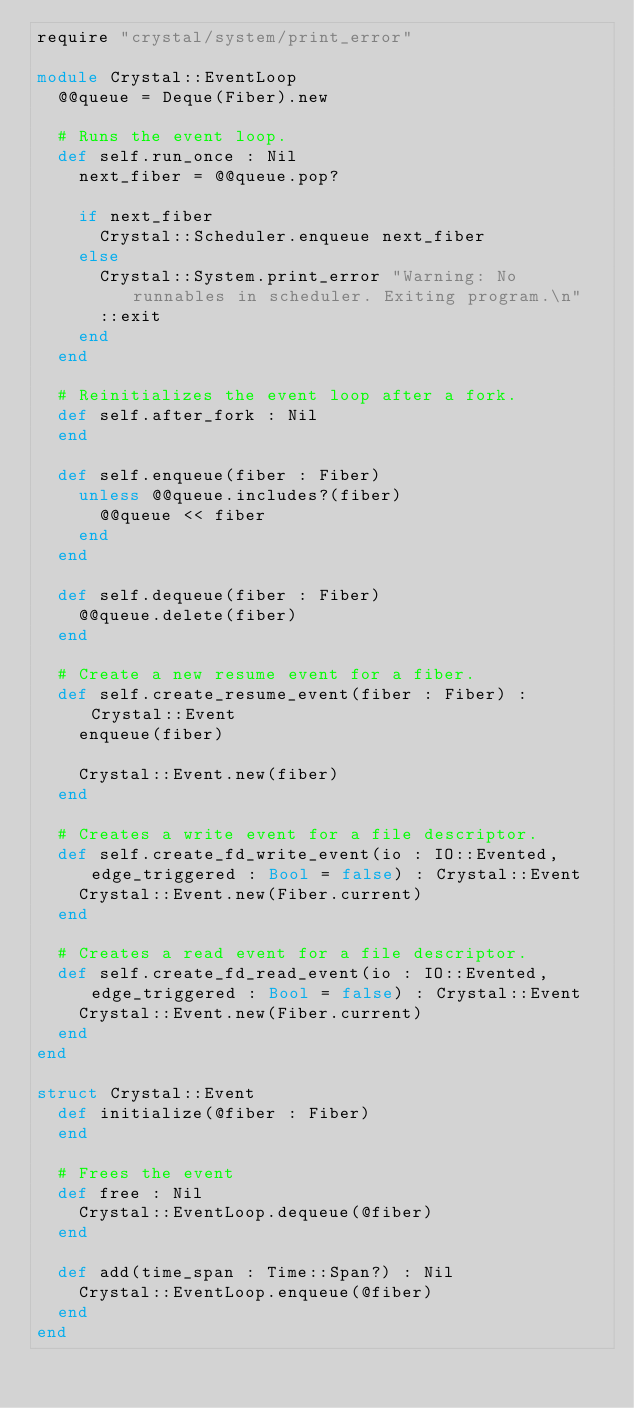Convert code to text. <code><loc_0><loc_0><loc_500><loc_500><_Crystal_>require "crystal/system/print_error"

module Crystal::EventLoop
  @@queue = Deque(Fiber).new

  # Runs the event loop.
  def self.run_once : Nil
    next_fiber = @@queue.pop?

    if next_fiber
      Crystal::Scheduler.enqueue next_fiber
    else
      Crystal::System.print_error "Warning: No runnables in scheduler. Exiting program.\n"
      ::exit
    end
  end

  # Reinitializes the event loop after a fork.
  def self.after_fork : Nil
  end

  def self.enqueue(fiber : Fiber)
    unless @@queue.includes?(fiber)
      @@queue << fiber
    end
  end

  def self.dequeue(fiber : Fiber)
    @@queue.delete(fiber)
  end

  # Create a new resume event for a fiber.
  def self.create_resume_event(fiber : Fiber) : Crystal::Event
    enqueue(fiber)

    Crystal::Event.new(fiber)
  end

  # Creates a write event for a file descriptor.
  def self.create_fd_write_event(io : IO::Evented, edge_triggered : Bool = false) : Crystal::Event
    Crystal::Event.new(Fiber.current)
  end

  # Creates a read event for a file descriptor.
  def self.create_fd_read_event(io : IO::Evented, edge_triggered : Bool = false) : Crystal::Event
    Crystal::Event.new(Fiber.current)
  end
end

struct Crystal::Event
  def initialize(@fiber : Fiber)
  end

  # Frees the event
  def free : Nil
    Crystal::EventLoop.dequeue(@fiber)
  end

  def add(time_span : Time::Span?) : Nil
    Crystal::EventLoop.enqueue(@fiber)
  end
end
</code> 